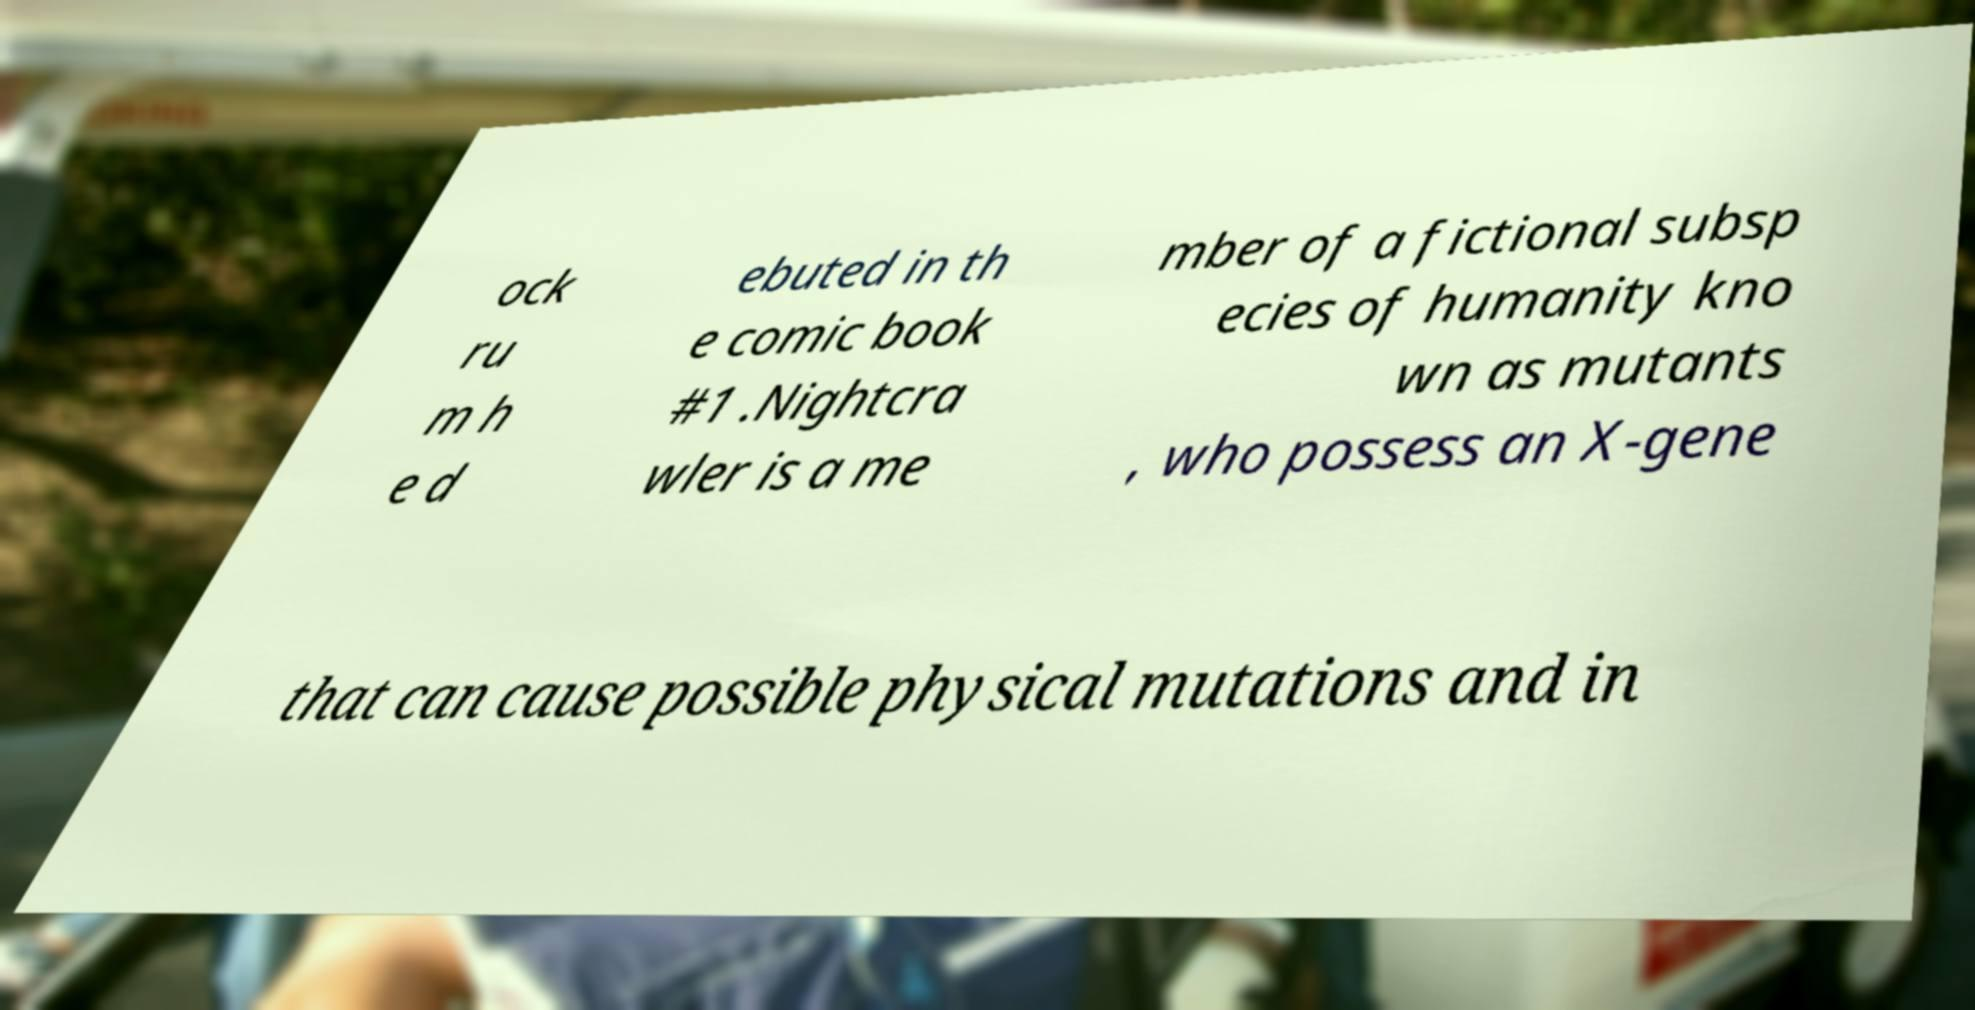Please identify and transcribe the text found in this image. ock ru m h e d ebuted in th e comic book #1 .Nightcra wler is a me mber of a fictional subsp ecies of humanity kno wn as mutants , who possess an X-gene that can cause possible physical mutations and in 